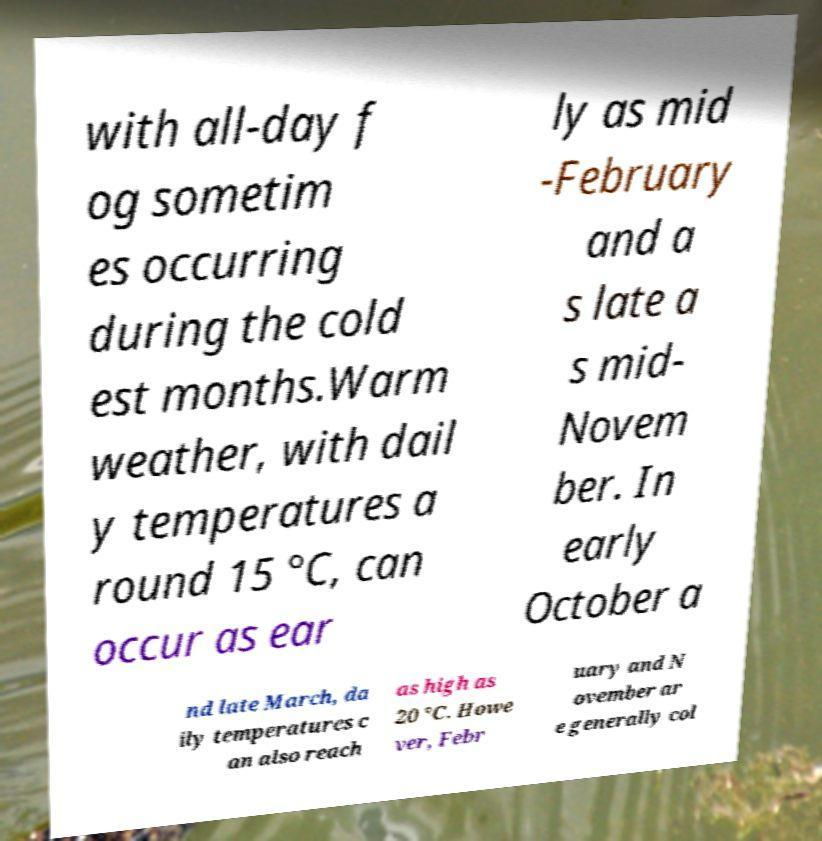Can you read and provide the text displayed in the image?This photo seems to have some interesting text. Can you extract and type it out for me? with all-day f og sometim es occurring during the cold est months.Warm weather, with dail y temperatures a round 15 °C, can occur as ear ly as mid -February and a s late a s mid- Novem ber. In early October a nd late March, da ily temperatures c an also reach as high as 20 °C. Howe ver, Febr uary and N ovember ar e generally col 